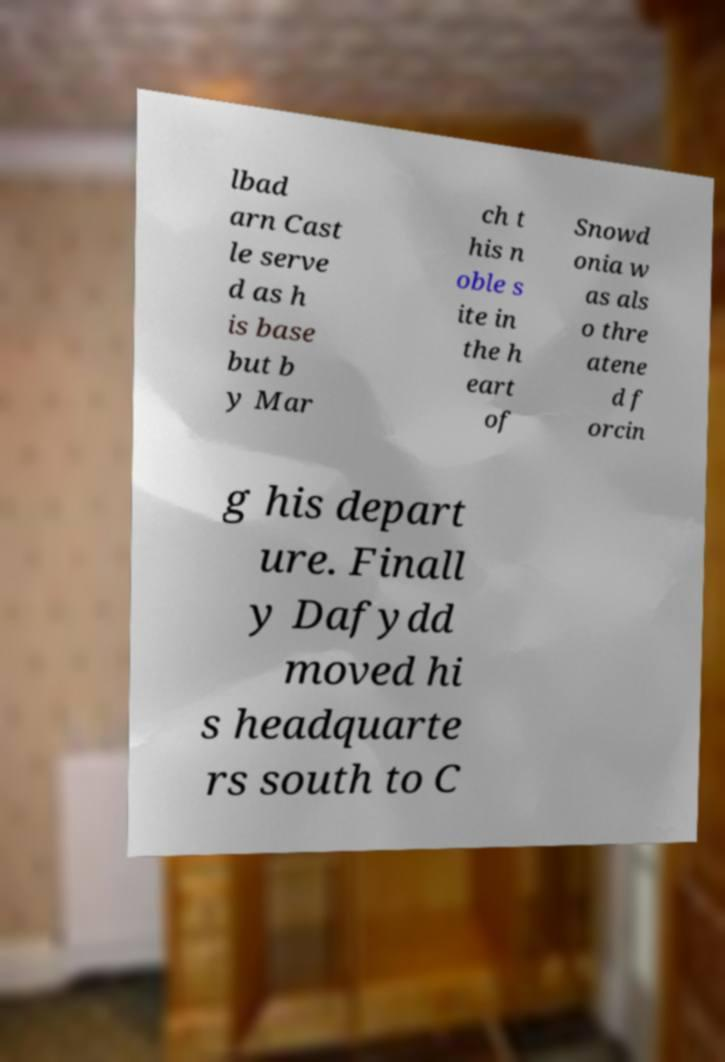Can you accurately transcribe the text from the provided image for me? lbad arn Cast le serve d as h is base but b y Mar ch t his n oble s ite in the h eart of Snowd onia w as als o thre atene d f orcin g his depart ure. Finall y Dafydd moved hi s headquarte rs south to C 